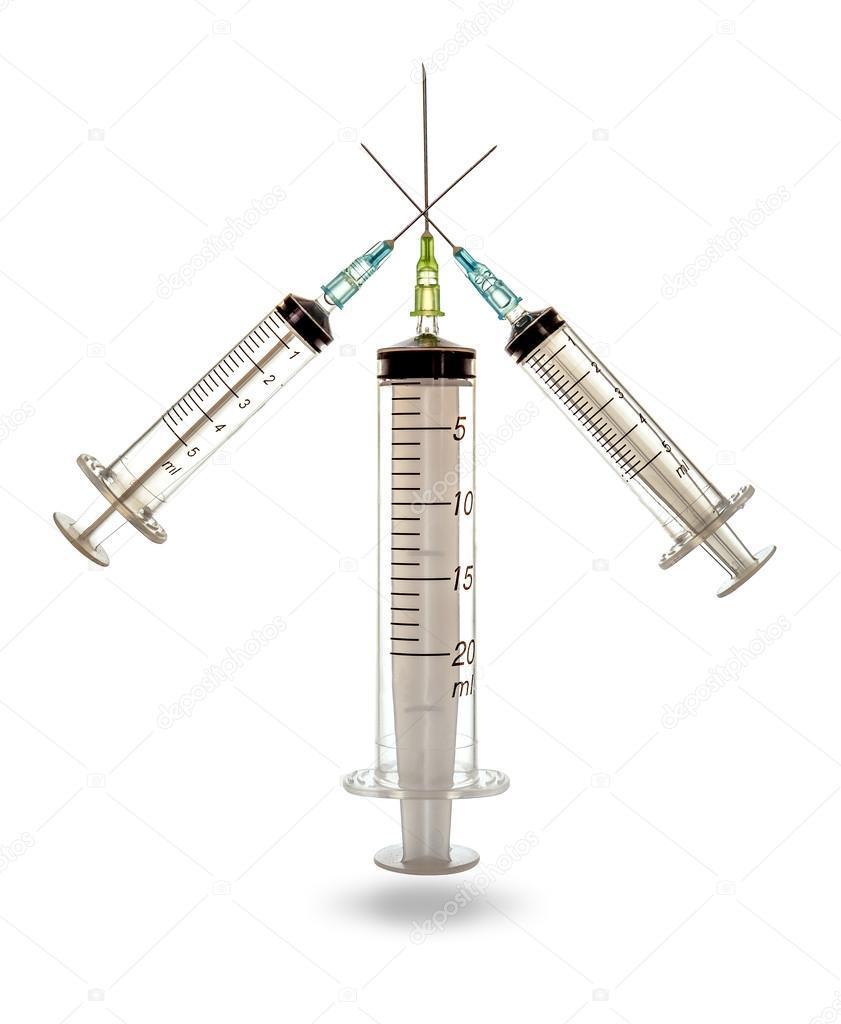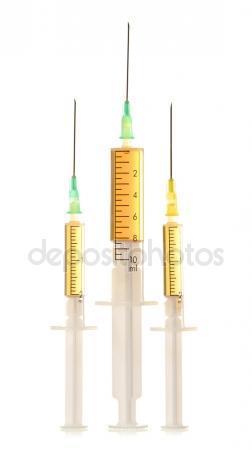The first image is the image on the left, the second image is the image on the right. Analyze the images presented: Is the assertion "The left image contains exactly three syringes." valid? Answer yes or no. Yes. 